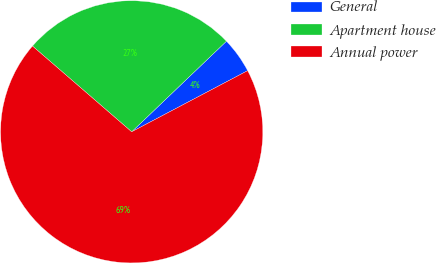Convert chart. <chart><loc_0><loc_0><loc_500><loc_500><pie_chart><fcel>General<fcel>Apartment house<fcel>Annual power<nl><fcel>4.42%<fcel>26.51%<fcel>69.07%<nl></chart> 